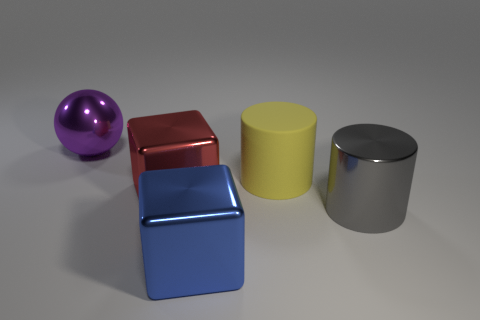What number of other objects are there of the same material as the yellow object?
Your answer should be compact. 0. There is a metal block that is to the left of the large blue metallic object; what is its size?
Provide a short and direct response. Large. How many shiny things are in front of the big purple shiny ball and to the left of the large gray metallic cylinder?
Your response must be concise. 2. There is a block behind the shiny block that is right of the large red object; what is its material?
Offer a very short reply. Metal. What is the material of the other thing that is the same shape as the large gray metallic thing?
Offer a very short reply. Rubber. Are any tiny green matte things visible?
Ensure brevity in your answer.  No. What is the shape of the large blue object that is made of the same material as the big gray cylinder?
Your answer should be very brief. Cube. What is the cylinder behind the big red thing made of?
Keep it short and to the point. Rubber. Do the object left of the red block and the big matte cylinder have the same color?
Make the answer very short. No. Is the number of big things that are in front of the gray cylinder greater than the number of large brown rubber cylinders?
Your answer should be very brief. Yes. 